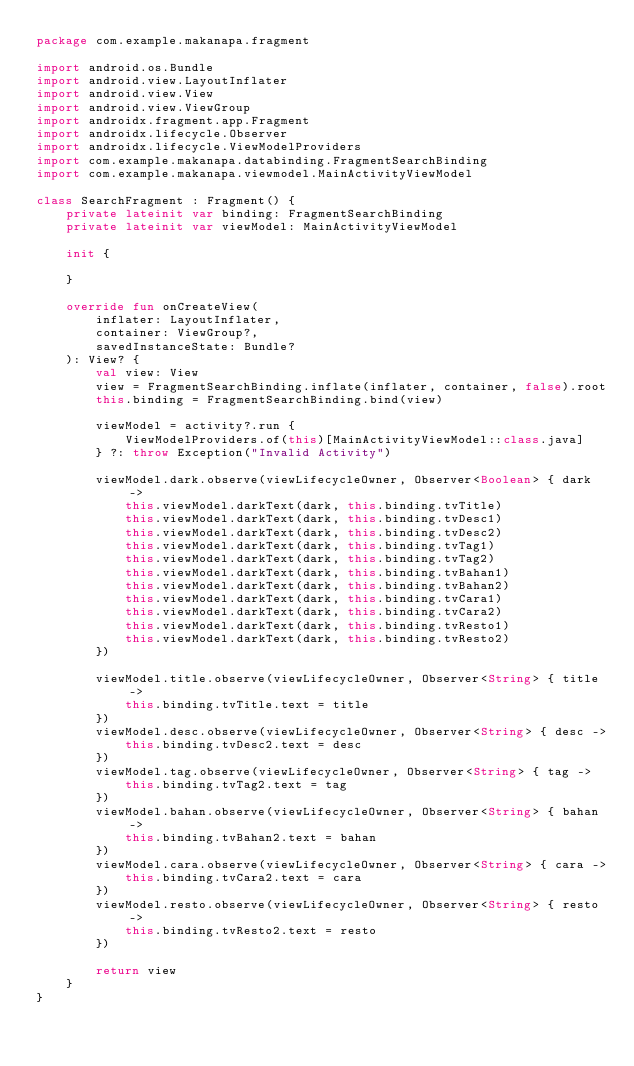Convert code to text. <code><loc_0><loc_0><loc_500><loc_500><_Kotlin_>package com.example.makanapa.fragment

import android.os.Bundle
import android.view.LayoutInflater
import android.view.View
import android.view.ViewGroup
import androidx.fragment.app.Fragment
import androidx.lifecycle.Observer
import androidx.lifecycle.ViewModelProviders
import com.example.makanapa.databinding.FragmentSearchBinding
import com.example.makanapa.viewmodel.MainActivityViewModel

class SearchFragment : Fragment() {
    private lateinit var binding: FragmentSearchBinding
    private lateinit var viewModel: MainActivityViewModel

    init {

    }

    override fun onCreateView(
        inflater: LayoutInflater,
        container: ViewGroup?,
        savedInstanceState: Bundle?
    ): View? {
        val view: View
        view = FragmentSearchBinding.inflate(inflater, container, false).root
        this.binding = FragmentSearchBinding.bind(view)

        viewModel = activity?.run {
            ViewModelProviders.of(this)[MainActivityViewModel::class.java]
        } ?: throw Exception("Invalid Activity")

        viewModel.dark.observe(viewLifecycleOwner, Observer<Boolean> { dark ->
            this.viewModel.darkText(dark, this.binding.tvTitle)
            this.viewModel.darkText(dark, this.binding.tvDesc1)
            this.viewModel.darkText(dark, this.binding.tvDesc2)
            this.viewModel.darkText(dark, this.binding.tvTag1)
            this.viewModel.darkText(dark, this.binding.tvTag2)
            this.viewModel.darkText(dark, this.binding.tvBahan1)
            this.viewModel.darkText(dark, this.binding.tvBahan2)
            this.viewModel.darkText(dark, this.binding.tvCara1)
            this.viewModel.darkText(dark, this.binding.tvCara2)
            this.viewModel.darkText(dark, this.binding.tvResto1)
            this.viewModel.darkText(dark, this.binding.tvResto2)
        })

        viewModel.title.observe(viewLifecycleOwner, Observer<String> { title ->
            this.binding.tvTitle.text = title
        })
        viewModel.desc.observe(viewLifecycleOwner, Observer<String> { desc ->
            this.binding.tvDesc2.text = desc
        })
        viewModel.tag.observe(viewLifecycleOwner, Observer<String> { tag ->
            this.binding.tvTag2.text = tag
        })
        viewModel.bahan.observe(viewLifecycleOwner, Observer<String> { bahan ->
            this.binding.tvBahan2.text = bahan
        })
        viewModel.cara.observe(viewLifecycleOwner, Observer<String> { cara ->
            this.binding.tvCara2.text = cara
        })
        viewModel.resto.observe(viewLifecycleOwner, Observer<String> { resto ->
            this.binding.tvResto2.text = resto
        })

        return view
    }
}</code> 